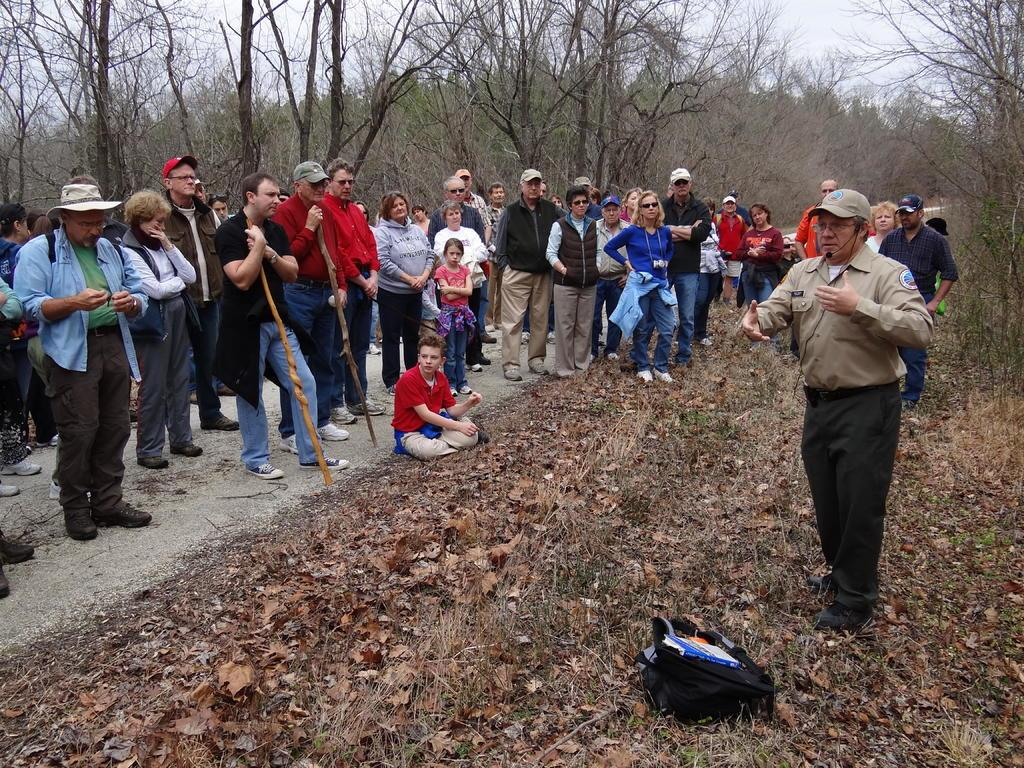What type of vegetation is at the bottom of the image? There is dry grass at the bottom of the image. Who or what can be seen in the foreground of the image? There are people in the foreground of the image. Where are the trees located in the image? There are trees in the right corner and in the background of the image. What is visible at the top of the image? The sky is visible at the top of the image. What type of badge is being worn by the trees in the image? There are no badges present in the image; it features people, dry grass, and trees. How do the pigs interact with the nerve in the image? There are no pigs or nerves present in the image. 